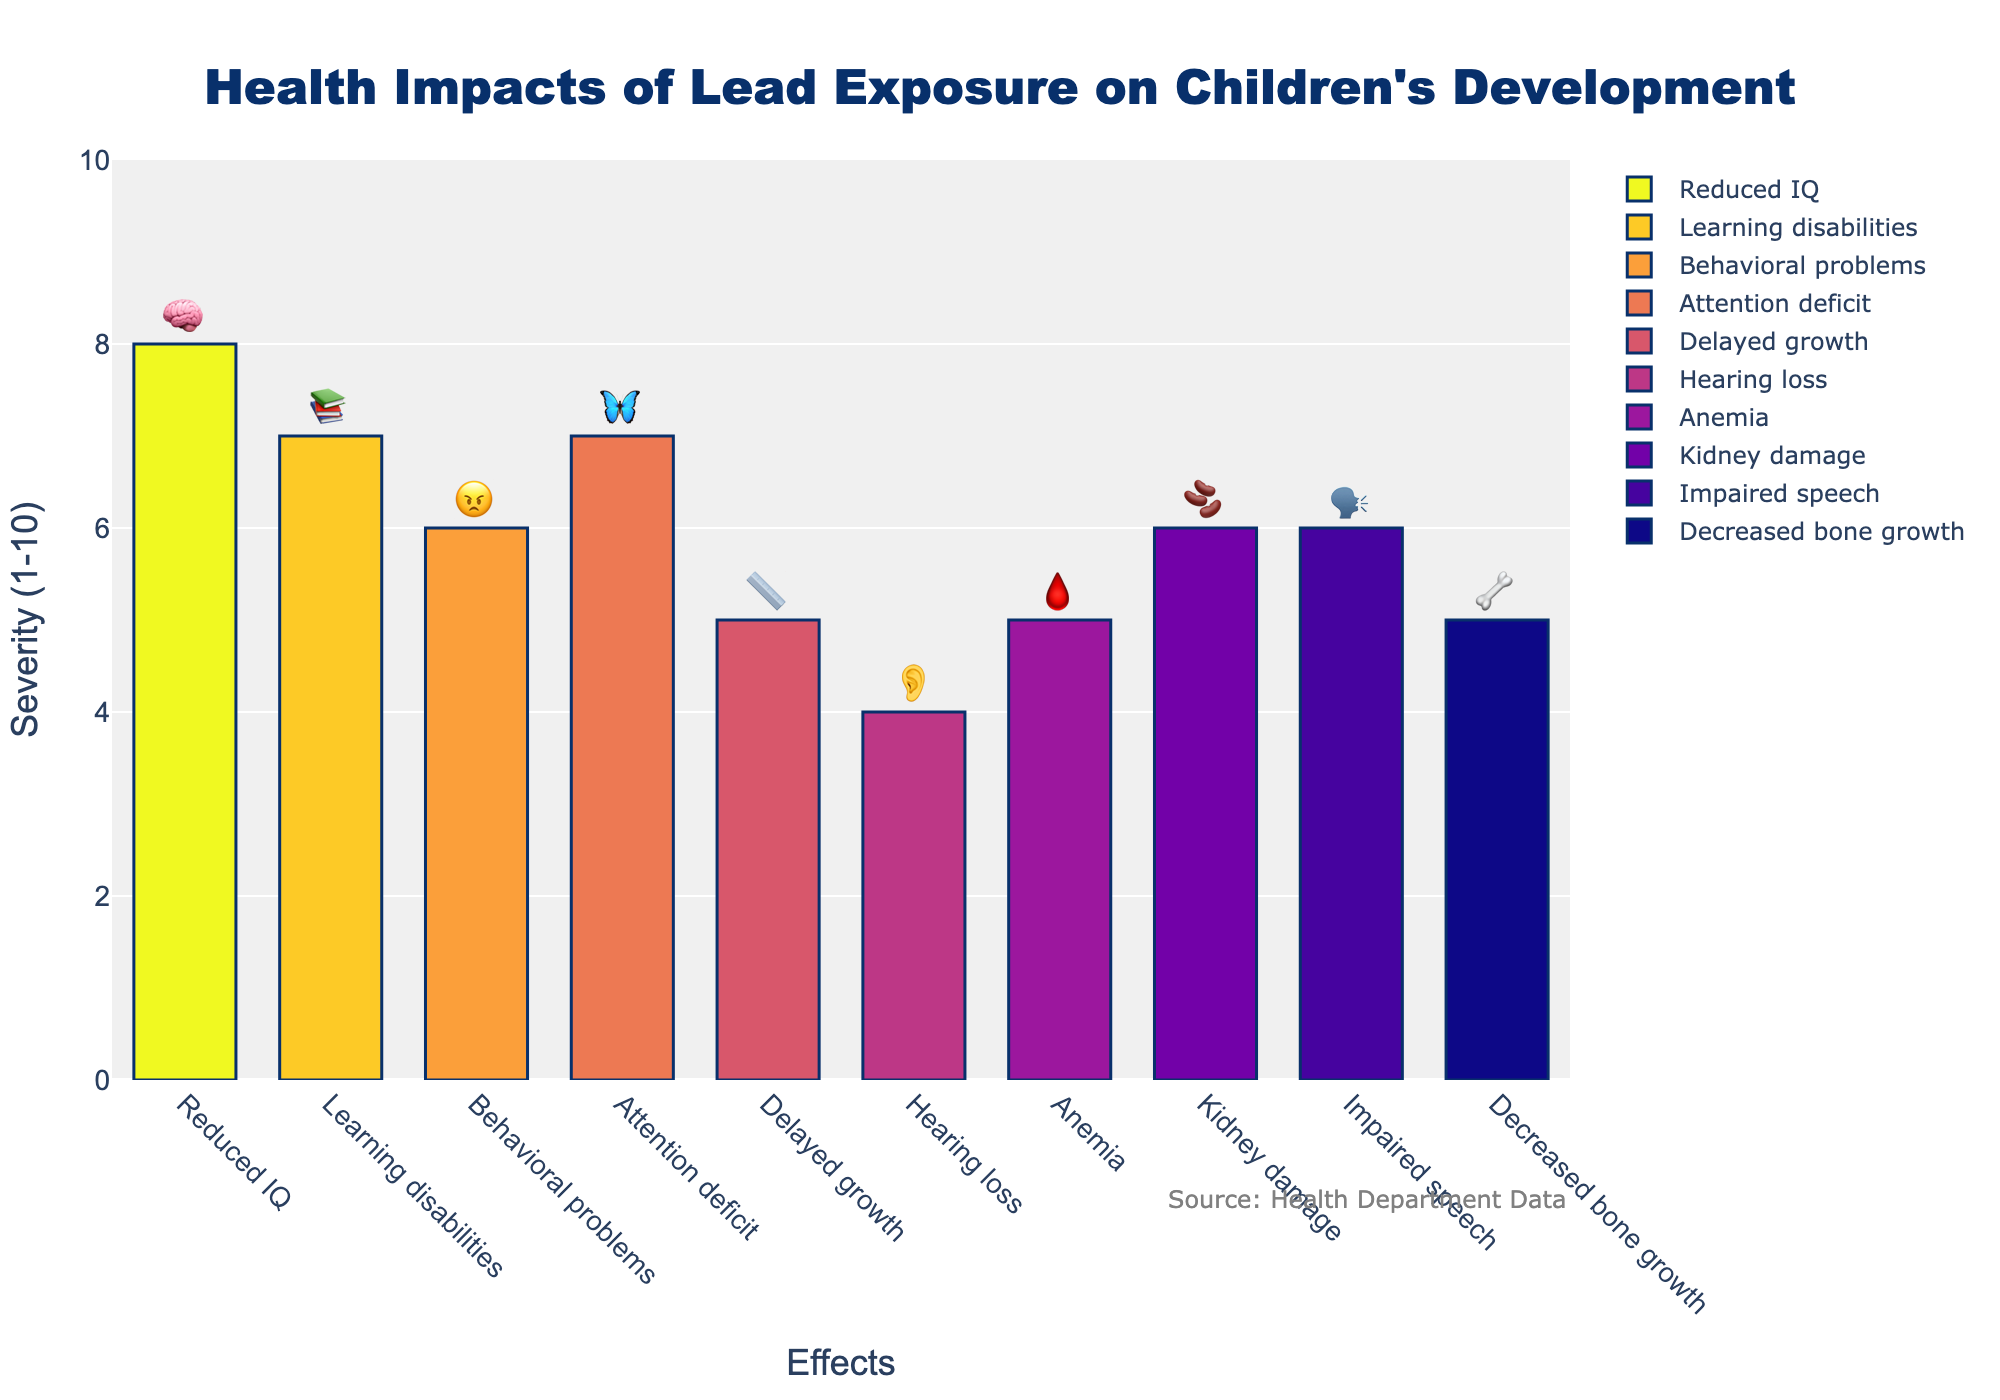How severe is the impact of lead exposure on reduced IQ in children? The severity of the impact of lead exposure on reduced IQ can be seen on the y-axis of the plot near the labeled 'Reduced IQ'. It has a severity score of 8, as indicated by the bar height. This is also visually supported by the emoji 🧠 placed on top of the bar.
Answer: 8 Which two effects have the highest severity scores and what are these scores? By looking for the tallest bars in the plot, we can identify 'Reduced IQ' with a severity score of 8 and both 'Learning disabilities' and 'Attention deficit' with scores of 7.
Answer: Reduced IQ: 8, Learning disabilities: 7, Attention deficit: 7 What's the difference in severity between hearing loss and attention deficit? Hearing loss has a severity score of 4, and attention deficit has a severity score of 7. The difference is calculated as 7 - 4 = 3.
Answer: 3 How does the severity of behavioral problems compare to kidney damage? By comparing the heights of the bars for 'Behavioral problems' (6) and 'Kidney damage' (6), we see that their severity scores are equal.
Answer: Equal Which effect has the least severity and what is the score? We identify the shortest bar, which is 'Hearing loss' and look at the y-axis for the severity score, which is 4.
Answer: Hearing loss: 4 What is the average severity of the categories with a severity score of 6? The categories with a severity score of 6 include 'Behavioral problems', 'Kidney damage', and 'Impaired speech'. The average severity is calculated as (6 + 6 + 6) / 3 = 18 / 3 = 6.
Answer: 6 What is the total severity score for all the effects combined? Adding the severity scores for each effect: 8 (Reduced IQ) + 7 (Learning disabilities) + 6 (Behavioral problems) + 7 (Attention deficit) + 5 (Delayed growth) + 4 (Hearing loss) + 5 (Anemia) + 6 (Kidney damage) + 6 (Impaired speech) + 5 (Decreased bone growth) = 59.
Answer: 59 What's the severity score for delayed growth, and what emoji is used to represent it? The plot shows 'Delayed growth' with a severity score of 5 and is represented with the 📏 emoji.
Answer: Severity: 5, Emoji: 📏 